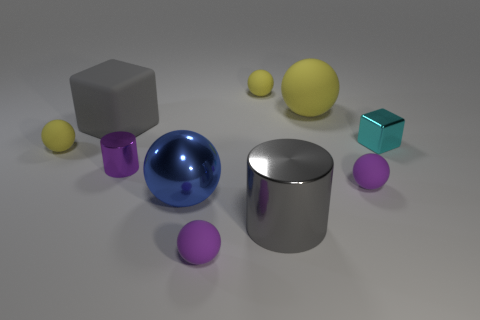Do the cyan object right of the shiny ball and the tiny cylinder have the same size?
Your response must be concise. Yes. What shape is the shiny thing that is right of the shiny ball and left of the tiny cyan object?
Make the answer very short. Cylinder. Are there more things that are left of the big shiny sphere than large blue cylinders?
Provide a short and direct response. Yes. There is a purple object that is the same material as the small cube; what size is it?
Offer a very short reply. Small. How many small rubber things have the same color as the small metal cylinder?
Your answer should be compact. 2. Does the small matte ball to the right of the gray metallic thing have the same color as the small cylinder?
Your answer should be very brief. Yes. Is the number of big yellow matte balls that are on the right side of the small cyan metal object the same as the number of small yellow rubber spheres behind the large gray block?
Your response must be concise. No. What color is the cube that is to the left of the large metallic sphere?
Give a very brief answer. Gray. Are there the same number of metallic cubes that are to the left of the small purple cylinder and green rubber cylinders?
Provide a short and direct response. Yes. What number of other things are the same shape as the tiny cyan shiny object?
Ensure brevity in your answer.  1. 